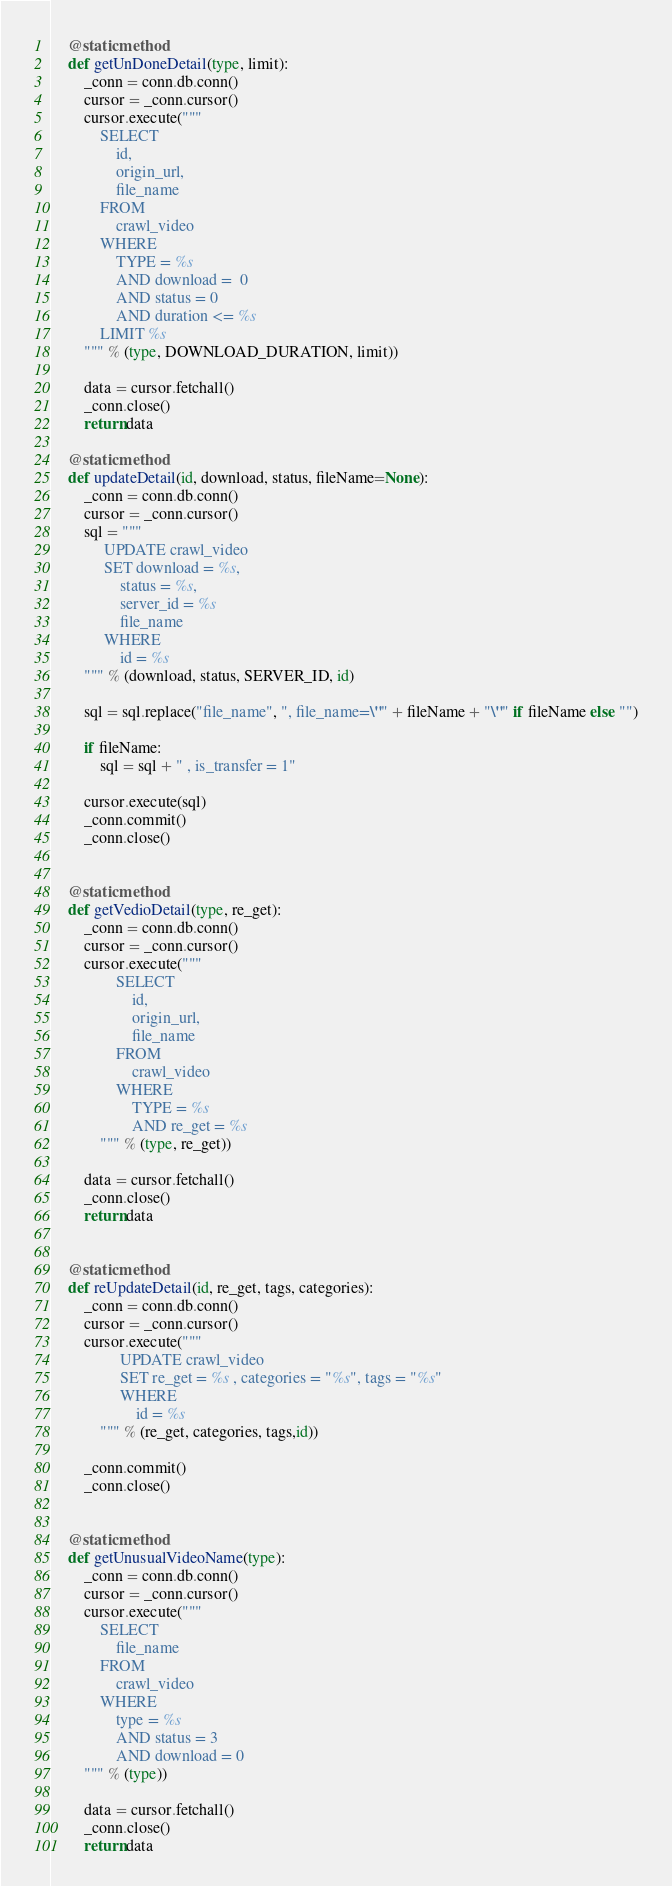Convert code to text. <code><loc_0><loc_0><loc_500><loc_500><_Python_>    @staticmethod
    def getUnDoneDetail(type, limit):
        _conn = conn.db.conn()
        cursor = _conn.cursor()
        cursor.execute("""
            SELECT
                id,
                origin_url,
                file_name 
            FROM
                crawl_video 
            WHERE
                TYPE = %s
                AND download =  0
                AND status = 0
                AND duration <= %s
            LIMIT %s
        """ % (type, DOWNLOAD_DURATION, limit))

        data = cursor.fetchall()
        _conn.close()
        return data

    @staticmethod
    def updateDetail(id, download, status, fileName=None):
        _conn = conn.db.conn()
        cursor = _conn.cursor()
        sql = """
             UPDATE crawl_video 
             SET download = %s,
                 status = %s,
                 server_id = %s
                 file_name
             WHERE
                 id = %s
        """ % (download, status, SERVER_ID, id)

        sql = sql.replace("file_name", ", file_name=\"" + fileName + "\"" if fileName else "")

        if fileName:
            sql = sql + " , is_transfer = 1"

        cursor.execute(sql)
        _conn.commit()
        _conn.close()


    @staticmethod
    def getVedioDetail(type, re_get):
        _conn = conn.db.conn()
        cursor = _conn.cursor()
        cursor.execute("""
                SELECT
                    id,
                    origin_url,
                    file_name 
                FROM
                    crawl_video 
                WHERE
                    TYPE = %s
                    AND re_get = %s
            """ % (type, re_get))

        data = cursor.fetchall()
        _conn.close()
        return data


    @staticmethod
    def reUpdateDetail(id, re_get, tags, categories):
        _conn = conn.db.conn()
        cursor = _conn.cursor()
        cursor.execute("""
                 UPDATE crawl_video 
                 SET re_get = %s , categories = "%s", tags = "%s"
                 WHERE
                     id = %s
            """ % (re_get, categories, tags,id))

        _conn.commit()
        _conn.close()


    @staticmethod
    def getUnusualVideoName(type):
        _conn = conn.db.conn()
        cursor = _conn.cursor()
        cursor.execute("""
            SELECT
                file_name 
            FROM
                crawl_video 
            WHERE
                type = %s
                AND status = 3
                AND download = 0
        """ % (type))

        data = cursor.fetchall()
        _conn.close()
        return data
</code> 